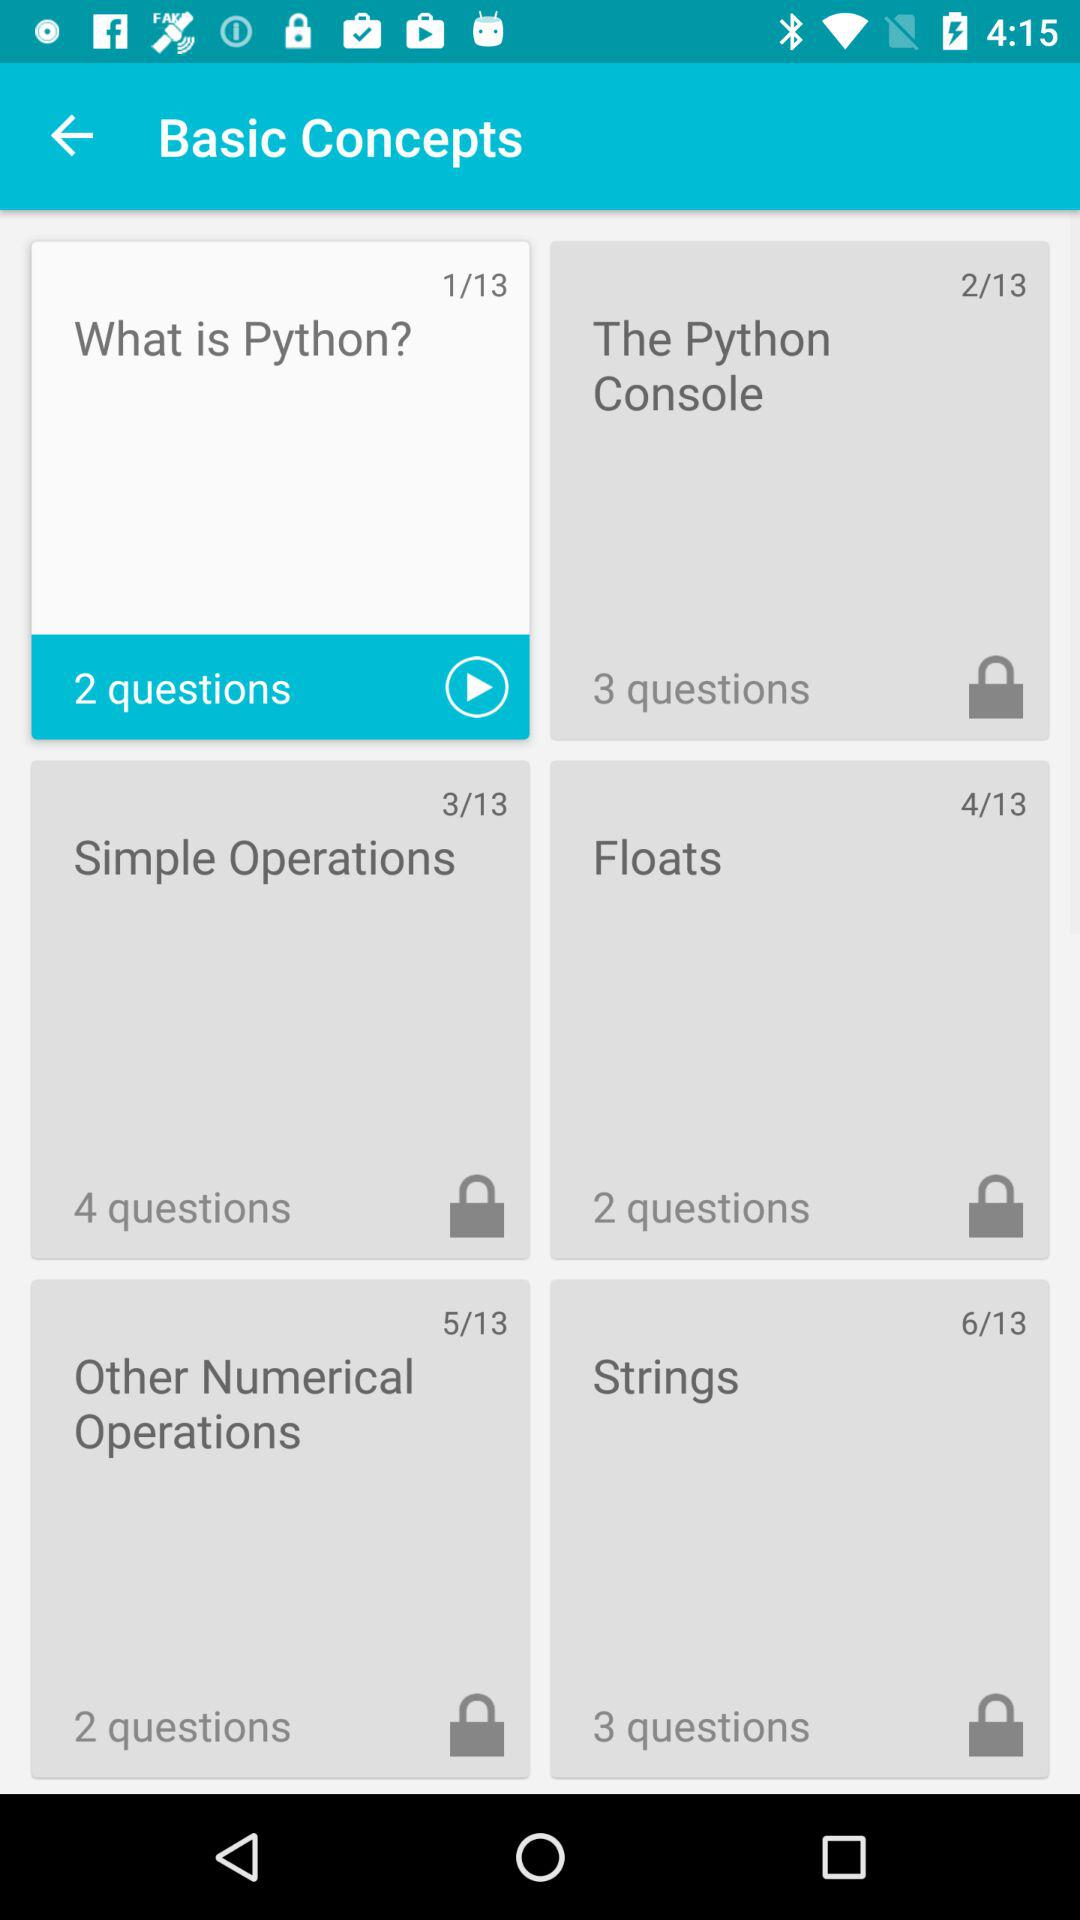Which is the unlocked slide? The unlocked slide is "What is Python?". 